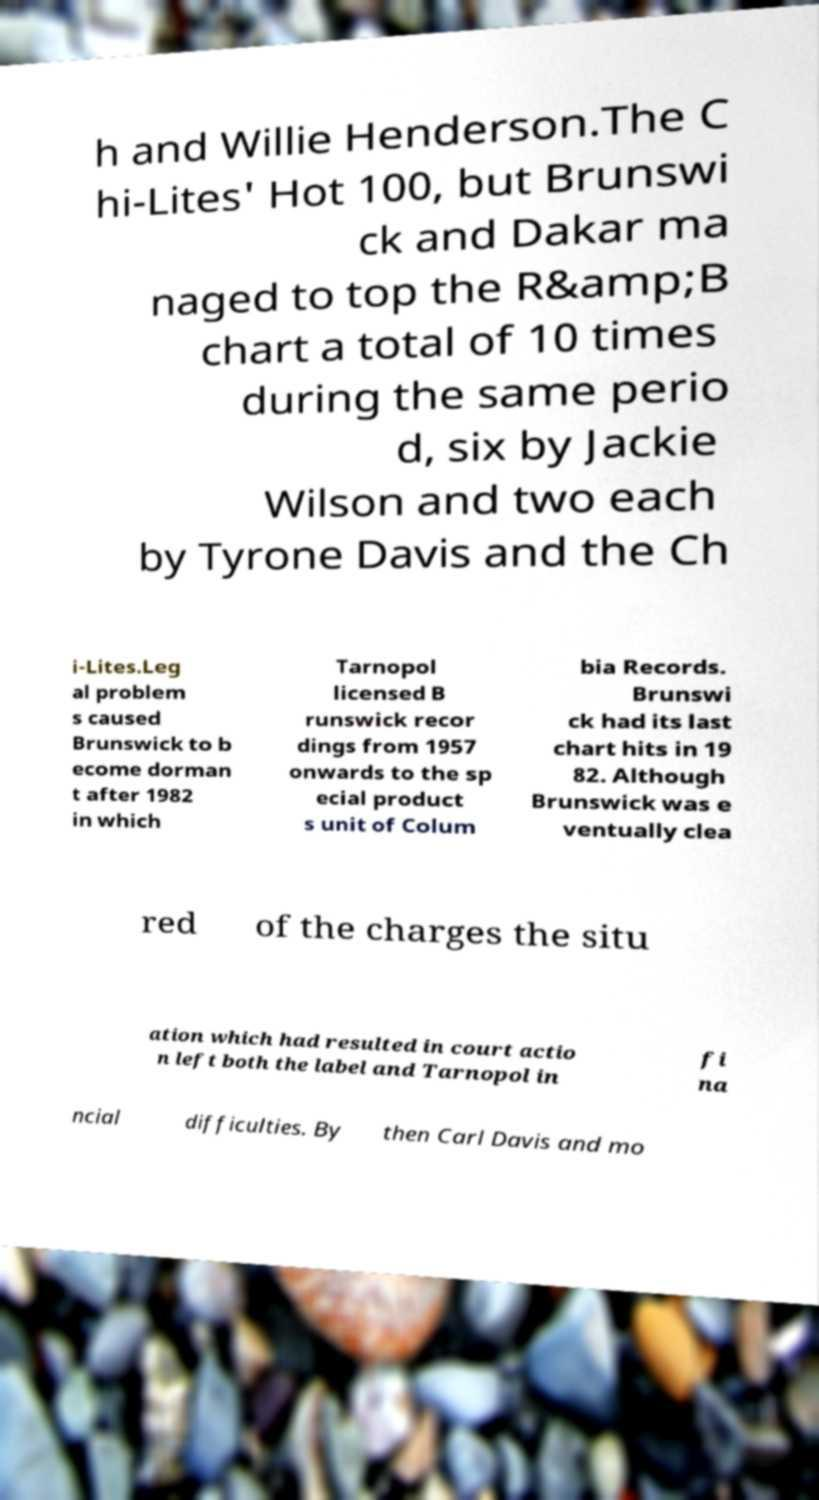Please identify and transcribe the text found in this image. h and Willie Henderson.The C hi-Lites' Hot 100, but Brunswi ck and Dakar ma naged to top the R&amp;B chart a total of 10 times during the same perio d, six by Jackie Wilson and two each by Tyrone Davis and the Ch i-Lites.Leg al problem s caused Brunswick to b ecome dorman t after 1982 in which Tarnopol licensed B runswick recor dings from 1957 onwards to the sp ecial product s unit of Colum bia Records. Brunswi ck had its last chart hits in 19 82. Although Brunswick was e ventually clea red of the charges the situ ation which had resulted in court actio n left both the label and Tarnopol in fi na ncial difficulties. By then Carl Davis and mo 